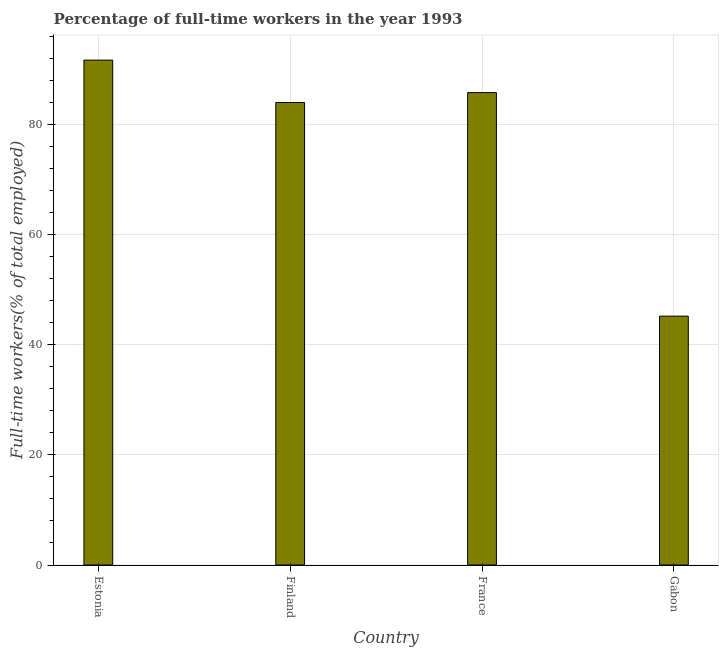Does the graph contain any zero values?
Your answer should be compact. No. Does the graph contain grids?
Make the answer very short. Yes. What is the title of the graph?
Provide a short and direct response. Percentage of full-time workers in the year 1993. What is the label or title of the X-axis?
Provide a succinct answer. Country. What is the label or title of the Y-axis?
Your answer should be very brief. Full-time workers(% of total employed). What is the percentage of full-time workers in Gabon?
Provide a short and direct response. 45.2. Across all countries, what is the maximum percentage of full-time workers?
Provide a succinct answer. 91.7. Across all countries, what is the minimum percentage of full-time workers?
Your answer should be very brief. 45.2. In which country was the percentage of full-time workers maximum?
Give a very brief answer. Estonia. In which country was the percentage of full-time workers minimum?
Offer a very short reply. Gabon. What is the sum of the percentage of full-time workers?
Make the answer very short. 306.7. What is the difference between the percentage of full-time workers in France and Gabon?
Provide a succinct answer. 40.6. What is the average percentage of full-time workers per country?
Keep it short and to the point. 76.67. What is the median percentage of full-time workers?
Ensure brevity in your answer.  84.9. In how many countries, is the percentage of full-time workers greater than 28 %?
Your answer should be compact. 4. What is the ratio of the percentage of full-time workers in Estonia to that in France?
Your answer should be compact. 1.07. Is the difference between the percentage of full-time workers in Finland and France greater than the difference between any two countries?
Your answer should be very brief. No. Is the sum of the percentage of full-time workers in Estonia and Finland greater than the maximum percentage of full-time workers across all countries?
Offer a terse response. Yes. What is the difference between the highest and the lowest percentage of full-time workers?
Provide a succinct answer. 46.5. In how many countries, is the percentage of full-time workers greater than the average percentage of full-time workers taken over all countries?
Your answer should be compact. 3. How many countries are there in the graph?
Keep it short and to the point. 4. What is the difference between two consecutive major ticks on the Y-axis?
Make the answer very short. 20. What is the Full-time workers(% of total employed) in Estonia?
Ensure brevity in your answer.  91.7. What is the Full-time workers(% of total employed) of France?
Make the answer very short. 85.8. What is the Full-time workers(% of total employed) in Gabon?
Offer a very short reply. 45.2. What is the difference between the Full-time workers(% of total employed) in Estonia and France?
Give a very brief answer. 5.9. What is the difference between the Full-time workers(% of total employed) in Estonia and Gabon?
Your response must be concise. 46.5. What is the difference between the Full-time workers(% of total employed) in Finland and France?
Give a very brief answer. -1.8. What is the difference between the Full-time workers(% of total employed) in Finland and Gabon?
Ensure brevity in your answer.  38.8. What is the difference between the Full-time workers(% of total employed) in France and Gabon?
Offer a terse response. 40.6. What is the ratio of the Full-time workers(% of total employed) in Estonia to that in Finland?
Provide a succinct answer. 1.09. What is the ratio of the Full-time workers(% of total employed) in Estonia to that in France?
Keep it short and to the point. 1.07. What is the ratio of the Full-time workers(% of total employed) in Estonia to that in Gabon?
Ensure brevity in your answer.  2.03. What is the ratio of the Full-time workers(% of total employed) in Finland to that in France?
Ensure brevity in your answer.  0.98. What is the ratio of the Full-time workers(% of total employed) in Finland to that in Gabon?
Provide a short and direct response. 1.86. What is the ratio of the Full-time workers(% of total employed) in France to that in Gabon?
Your answer should be compact. 1.9. 